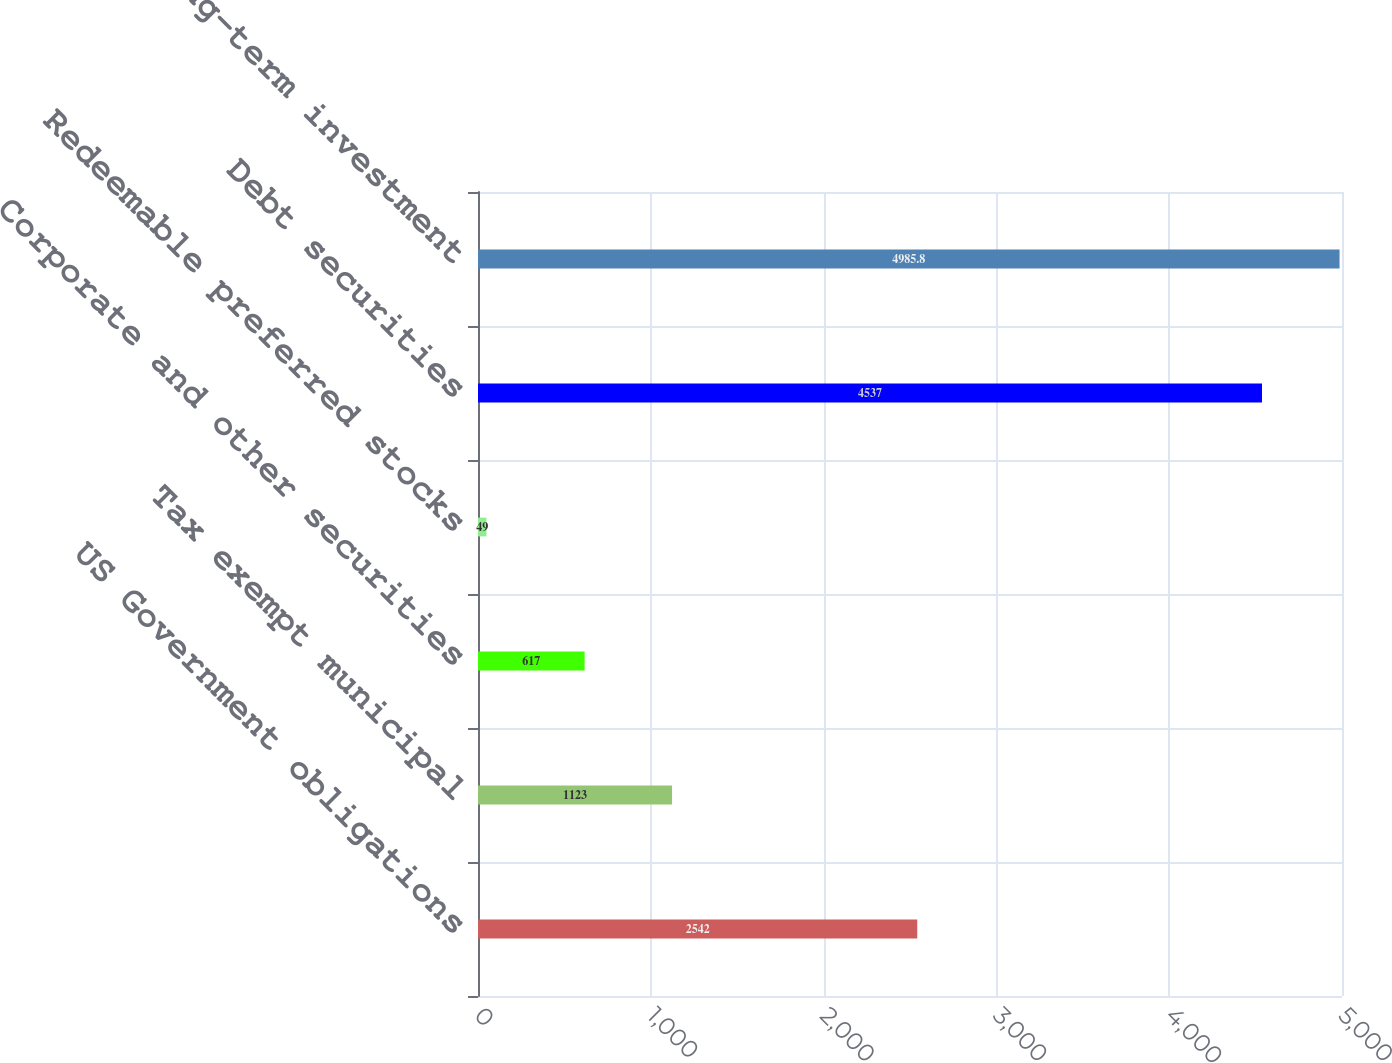<chart> <loc_0><loc_0><loc_500><loc_500><bar_chart><fcel>US Government obligations<fcel>Tax exempt municipal<fcel>Corporate and other securities<fcel>Redeemable preferred stocks<fcel>Debt securities<fcel>Long-term investment<nl><fcel>2542<fcel>1123<fcel>617<fcel>49<fcel>4537<fcel>4985.8<nl></chart> 